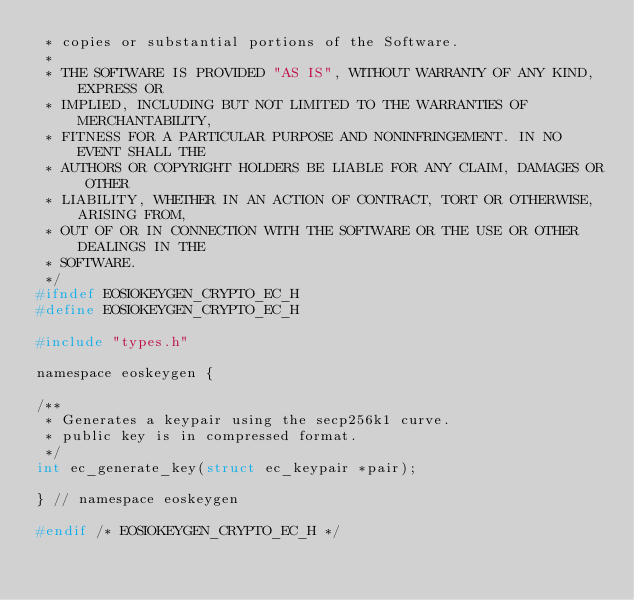Convert code to text. <code><loc_0><loc_0><loc_500><loc_500><_C_> * copies or substantial portions of the Software.
 *
 * THE SOFTWARE IS PROVIDED "AS IS", WITHOUT WARRANTY OF ANY KIND, EXPRESS OR
 * IMPLIED, INCLUDING BUT NOT LIMITED TO THE WARRANTIES OF MERCHANTABILITY,
 * FITNESS FOR A PARTICULAR PURPOSE AND NONINFRINGEMENT. IN NO EVENT SHALL THE
 * AUTHORS OR COPYRIGHT HOLDERS BE LIABLE FOR ANY CLAIM, DAMAGES OR OTHER
 * LIABILITY, WHETHER IN AN ACTION OF CONTRACT, TORT OR OTHERWISE, ARISING FROM,
 * OUT OF OR IN CONNECTION WITH THE SOFTWARE OR THE USE OR OTHER DEALINGS IN THE
 * SOFTWARE.
 */
#ifndef EOSIOKEYGEN_CRYPTO_EC_H
#define EOSIOKEYGEN_CRYPTO_EC_H

#include "types.h"

namespace eoskeygen {

/**
 * Generates a keypair using the secp256k1 curve.
 * public key is in compressed format.
 */
int ec_generate_key(struct ec_keypair *pair);

} // namespace eoskeygen

#endif /* EOSIOKEYGEN_CRYPTO_EC_H */
</code> 